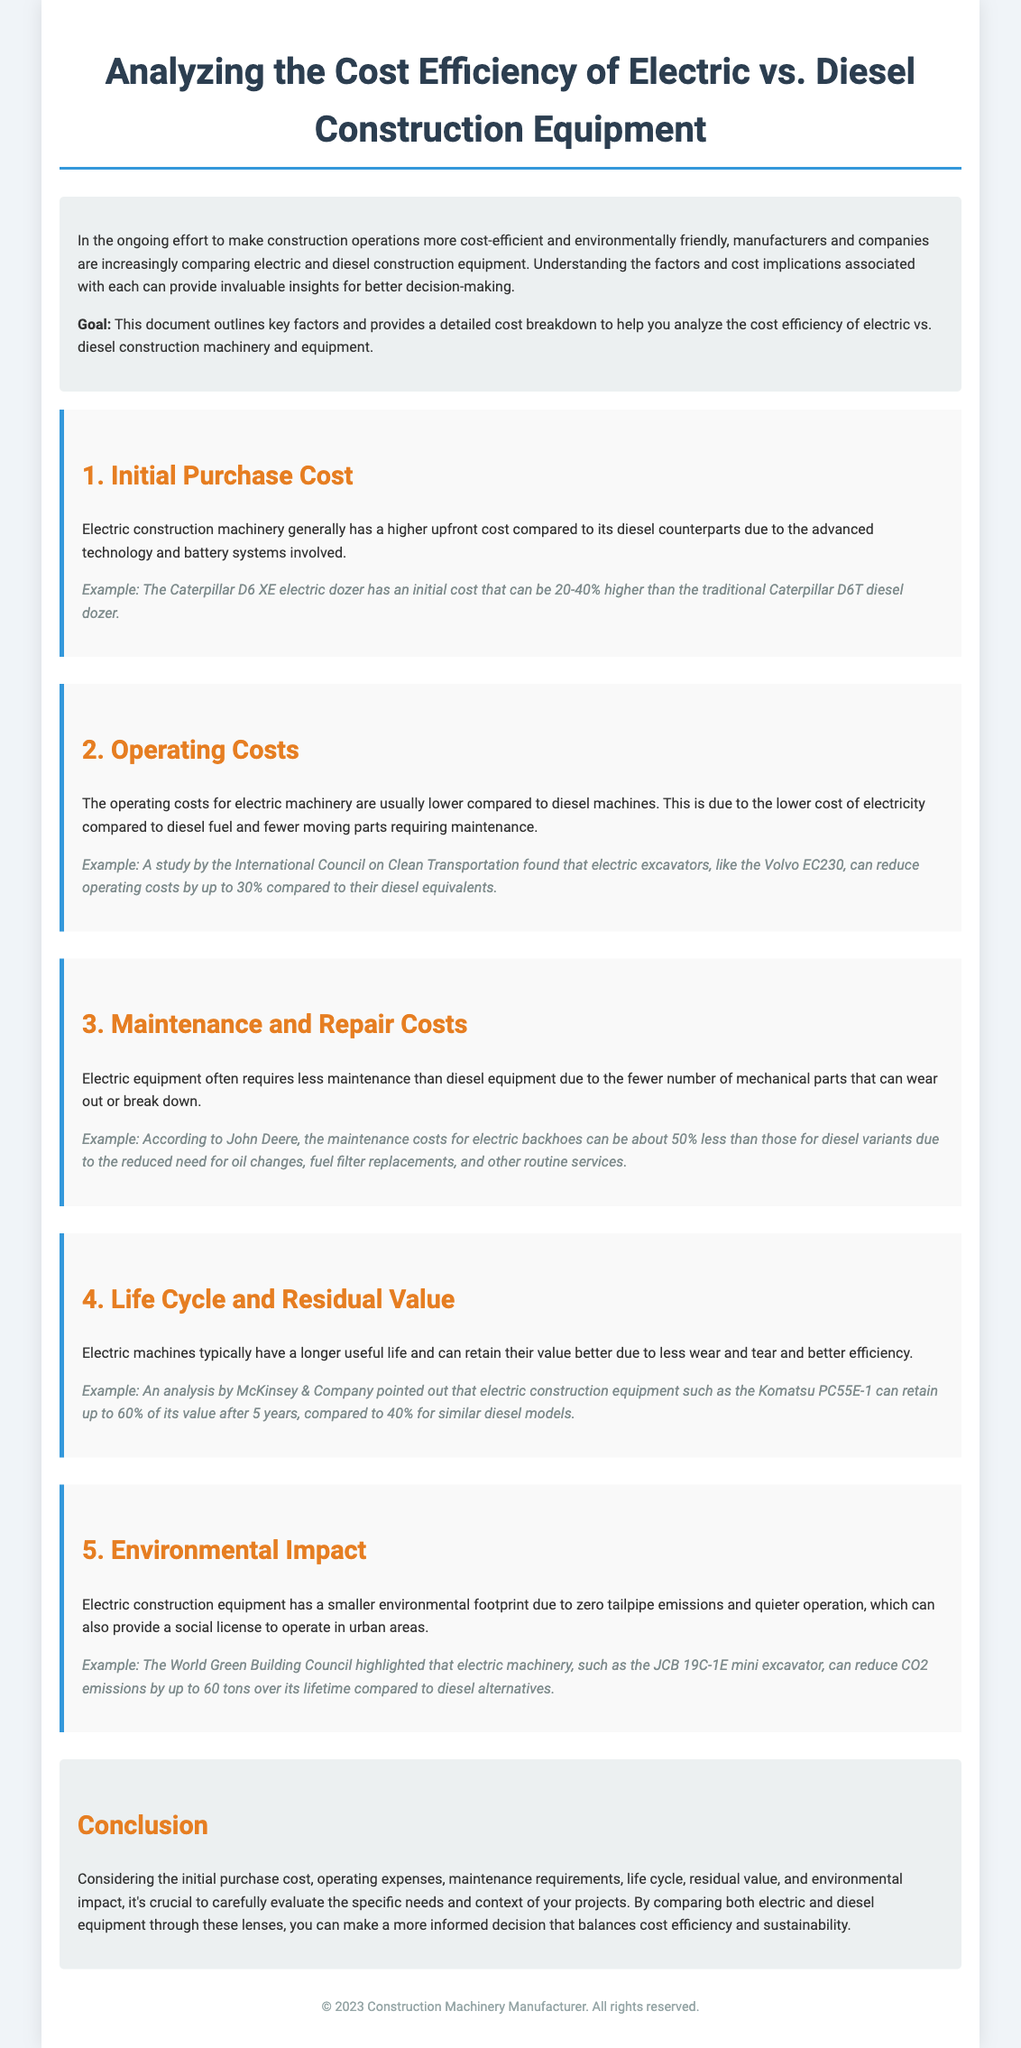What is the main goal of the document? The goal is outlined in the introduction section, indicating that it provides insights for better decision-making regarding electric vs. diesel construction equipment.
Answer: Better decision-making What is the initial purchase cost of electric machinery compared to diesel? The document states that electric machinery has a higher upfront cost due to advanced technology and battery systems.
Answer: Higher upfront cost By what percentage can operating costs of electric excavators reduce compared to diesel? The operating costs can reduce by up to 30% as mentioned in the example under operating costs.
Answer: Up to 30% What is the maintenance cost difference for electric backhoes compared to diesel? According to the document, maintenance costs for electric backhoes can be about 50% less than diesel variants.
Answer: About 50% less How much value can electric construction equipment retain after 5 years? An analysis by McKinsey & Company shows electric construction equipment can retain up to 60% of its value after 5 years.
Answer: Up to 60% What is the environmental impact of electric construction equipment compared to diesel alternatives? The document highlights that electric machinery can reduce CO2 emissions significantly over its lifetime.
Answer: Reduce CO2 emissions What is one of the key factors to consider in the cost analysis? The document lists several key factors, one of which is operating costs.
Answer: Operating costs Which company produces the electric D6 XE dozer? The caterpillar D6 XE electric dozer is produced by Caterpillar.
Answer: Caterpillar What is one example of electric construction machinery mentioned in the document? The document mentions the JCB 19C-1E mini excavator as an example of electric machinery.
Answer: JCB 19C-1E mini excavator 